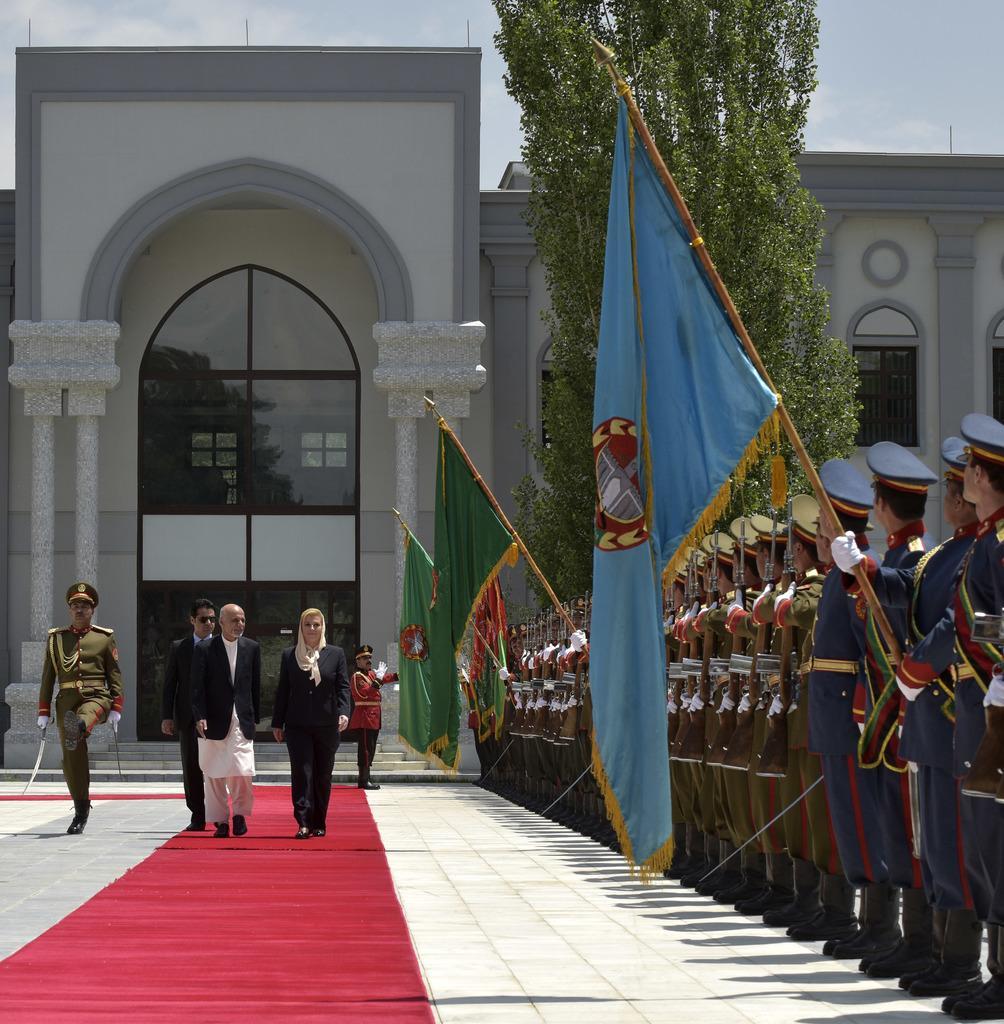Describe this image in one or two sentences. In this image, there is an outside view. There are some persons on the right side of the image holding flags with their hands. There are three persons in the bottom left of the image walking on the carpet. There is a building and tree in the middle of the image. 